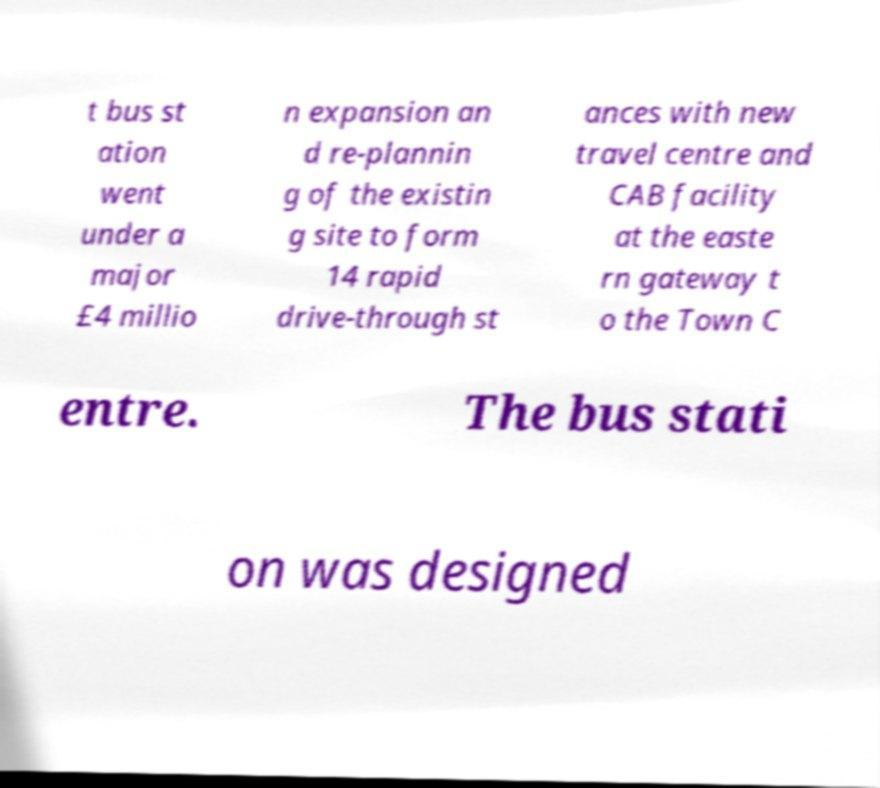I need the written content from this picture converted into text. Can you do that? t bus st ation went under a major £4 millio n expansion an d re-plannin g of the existin g site to form 14 rapid drive-through st ances with new travel centre and CAB facility at the easte rn gateway t o the Town C entre. The bus stati on was designed 